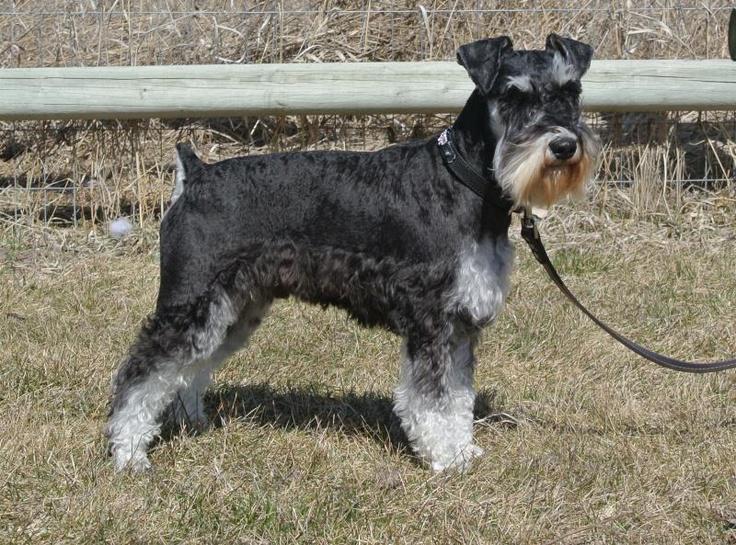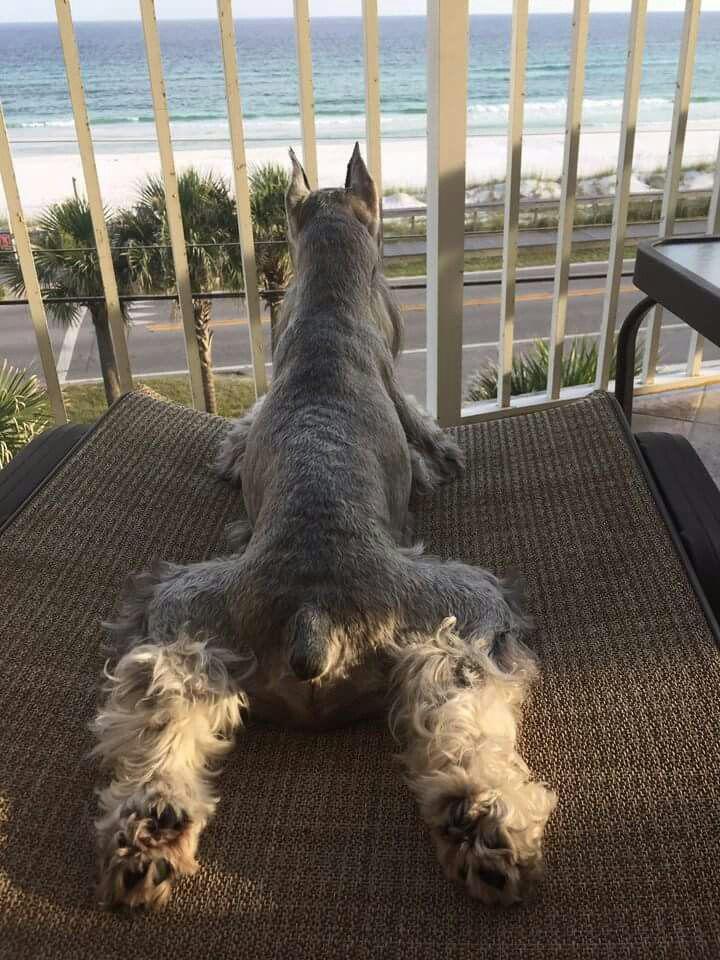The first image is the image on the left, the second image is the image on the right. Considering the images on both sides, is "The right and left images contain the same number of dogs." valid? Answer yes or no. Yes. The first image is the image on the left, the second image is the image on the right. Considering the images on both sides, is "There are two dogs in total." valid? Answer yes or no. Yes. 